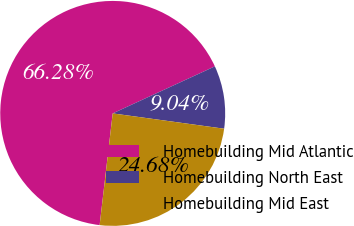<chart> <loc_0><loc_0><loc_500><loc_500><pie_chart><fcel>Homebuilding Mid Atlantic<fcel>Homebuilding North East<fcel>Homebuilding Mid East<nl><fcel>66.28%<fcel>9.04%<fcel>24.68%<nl></chart> 